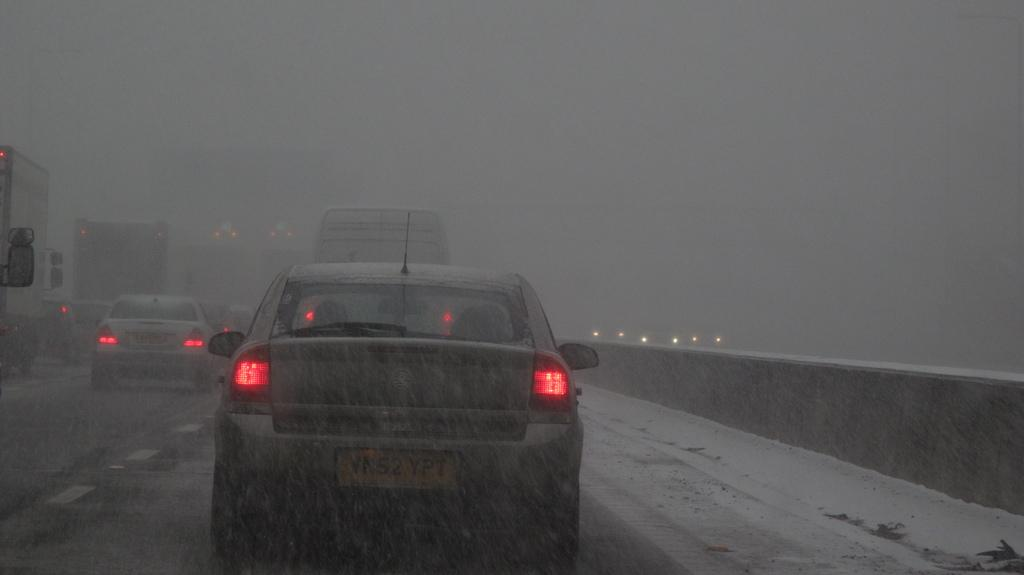What can be seen on the road in the image? There are motor vehicles on the road in the image. What is happening in the background of the image? There is snowfall visible in the image. What type of fuel is being used by the motor vehicles in the image? The provided facts do not mention the type of fuel being used by the motor vehicles, so it cannot be determined from the image. Can you see any bananas or wine in the image? There are no bananas or wine present in the image. 